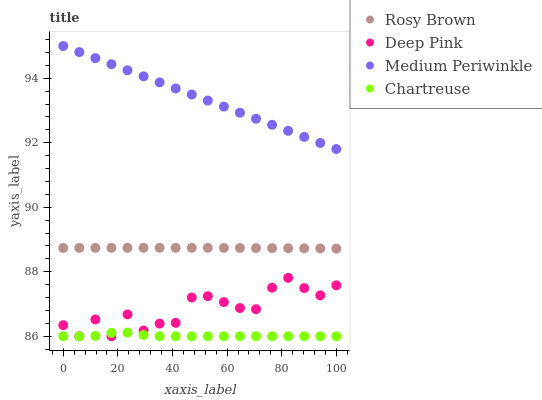Does Chartreuse have the minimum area under the curve?
Answer yes or no. Yes. Does Medium Periwinkle have the maximum area under the curve?
Answer yes or no. Yes. Does Rosy Brown have the minimum area under the curve?
Answer yes or no. No. Does Rosy Brown have the maximum area under the curve?
Answer yes or no. No. Is Medium Periwinkle the smoothest?
Answer yes or no. Yes. Is Deep Pink the roughest?
Answer yes or no. Yes. Is Rosy Brown the smoothest?
Answer yes or no. No. Is Rosy Brown the roughest?
Answer yes or no. No. Does Chartreuse have the lowest value?
Answer yes or no. Yes. Does Rosy Brown have the lowest value?
Answer yes or no. No. Does Medium Periwinkle have the highest value?
Answer yes or no. Yes. Does Rosy Brown have the highest value?
Answer yes or no. No. Is Chartreuse less than Medium Periwinkle?
Answer yes or no. Yes. Is Medium Periwinkle greater than Rosy Brown?
Answer yes or no. Yes. Does Deep Pink intersect Chartreuse?
Answer yes or no. Yes. Is Deep Pink less than Chartreuse?
Answer yes or no. No. Is Deep Pink greater than Chartreuse?
Answer yes or no. No. Does Chartreuse intersect Medium Periwinkle?
Answer yes or no. No. 